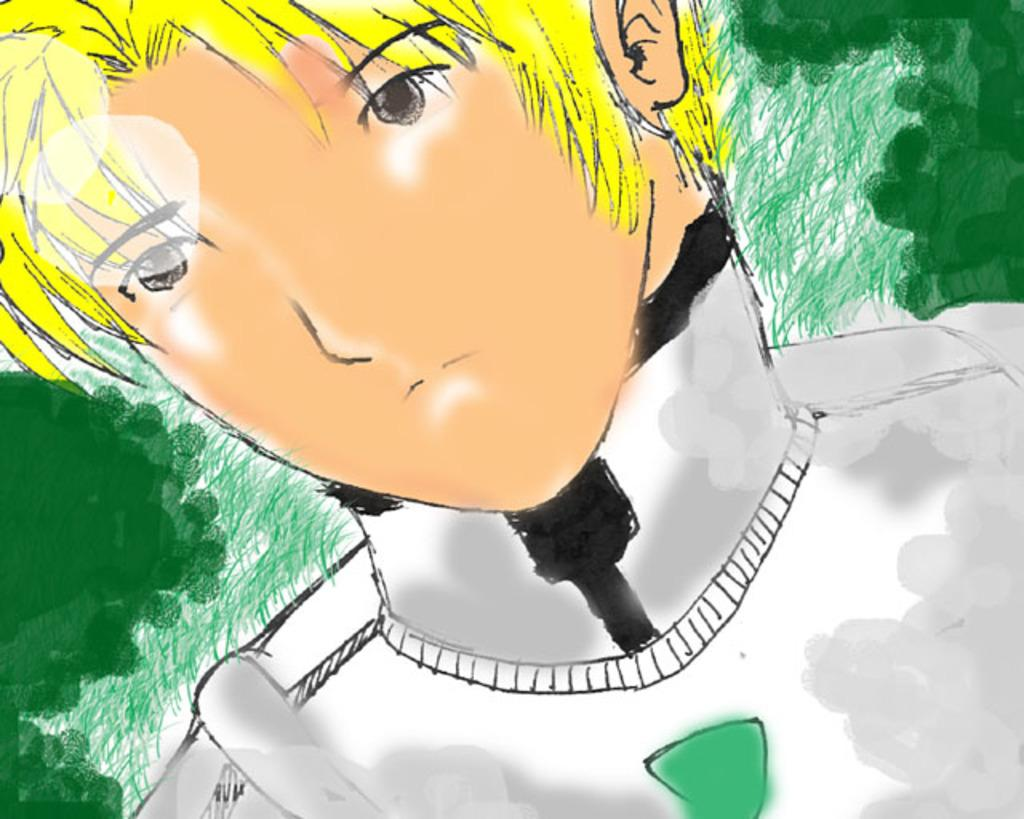What type of image is being described? The image is graphical in nature. Can you describe the main subject in the image? There is a person in the center of the image. What colors are used in the background of the image? The background of the image is green and white colored. What type of rabbit is sitting next to the person in the image? There is no rabbit present in the image; it only features a person in the center. 